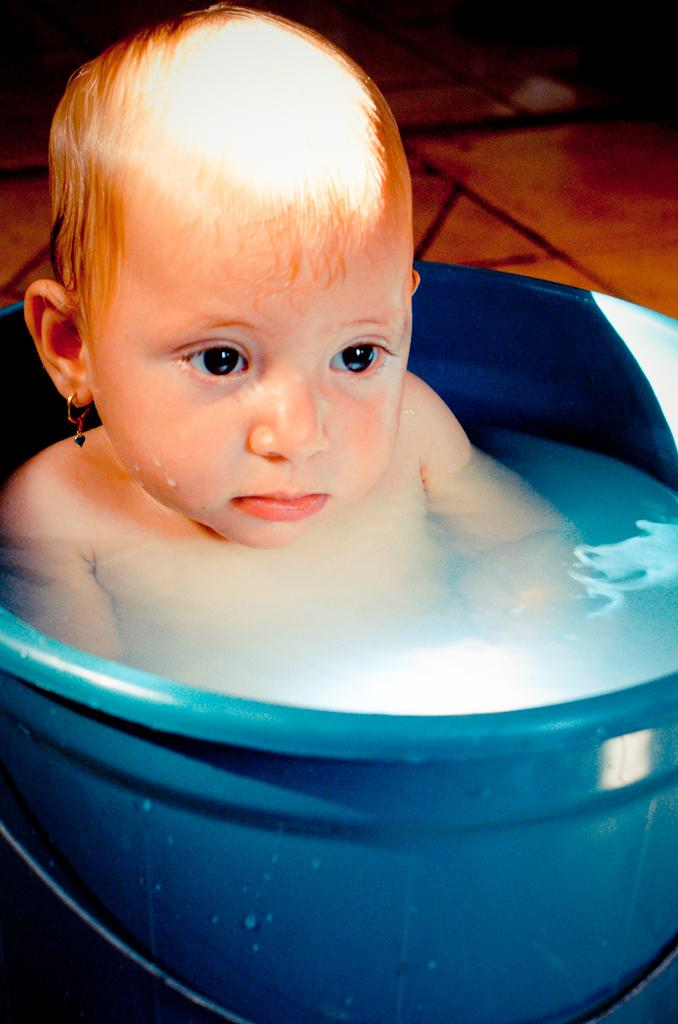What is the main subject of the image? The main subject of the image is a kid. What is the kid doing in the image? The kid is in a bucket of water. What type of surface can be seen in the background of the image? There are tiles visible in the background of the image. What type of animals can be seen at the zoo in the image? There is no zoo present in the image, so it's not possible to determine what, if any, animals might be seen. 